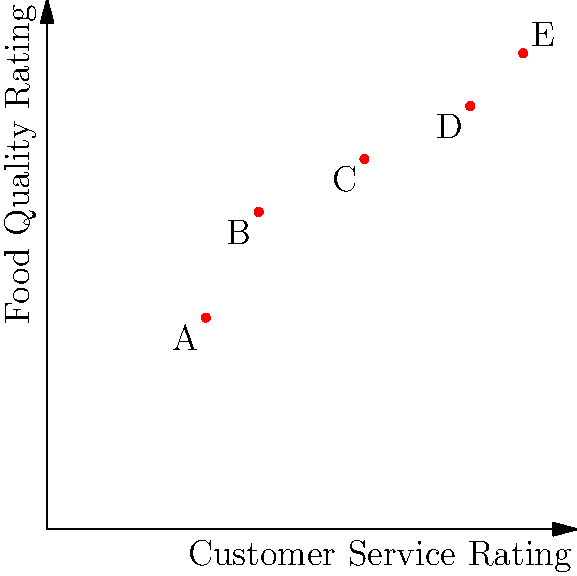As a Yelp reviewer, you've plotted customer ratings for five restaurants (A, B, C, D, and E) on a scatter plot. The x-axis represents Customer Service Rating, and the y-axis represents Food Quality Rating. Both axes range from 0 to 5. Which restaurant shows the best overall performance based on these two factors, and what are its approximate ratings? To determine the best overall performance, we need to consider both the Customer Service Rating and Food Quality Rating for each restaurant. The ideal position would be towards the top-right corner of the plot, indicating high ratings in both categories.

Let's analyze each restaurant's position:

1. Restaurant A: Approximately (1.5, 2) - Low ratings in both categories
2. Restaurant B: Approximately (2, 3) - Below average in both categories
3. Restaurant C: Approximately (3, 3.5) - Average in both categories
4. Restaurant D: Approximately (4, 4) - Above average in both categories
5. Restaurant E: Approximately (4.5, 4.5) - Highest ratings in both categories

Restaurant E has the highest position on both axes, indicating the best overall performance. Its approximate ratings are:

Customer Service Rating: 4.5
Food Quality Rating: 4.5

Therefore, Restaurant E shows the best overall performance based on these two factors.
Answer: Restaurant E, with ratings of approximately (4.5, 4.5) 